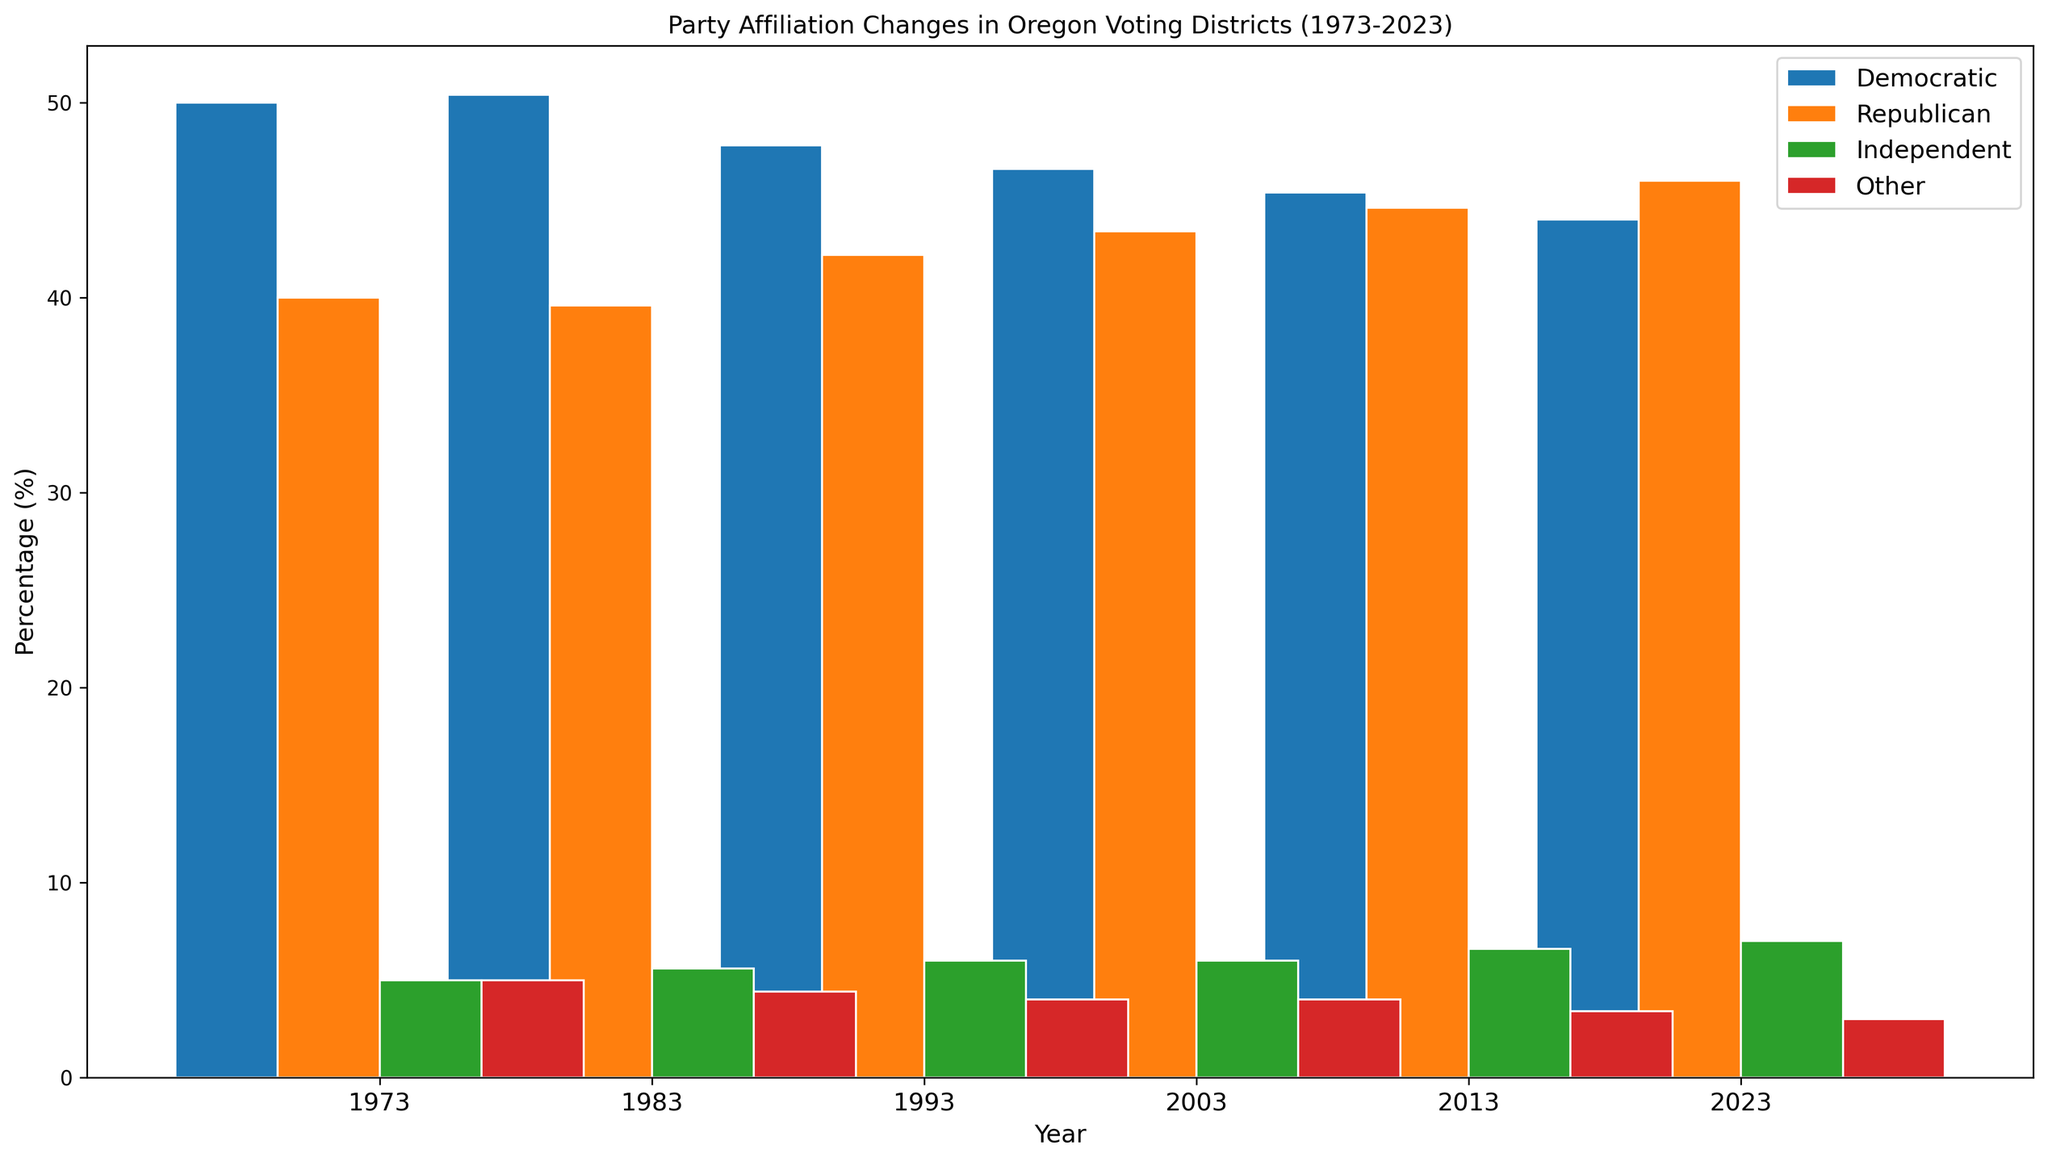What is the average percentage of Democratic affiliation across all years? Calculate the mean of the Democratic values for each year: (60+55+50+45+40+58+54+51+46+43+55+50+48+44+42+53+49+47+43+41+52+48+45+42+40+50+46+44+41+39) / 30 = 47.8
Answer: 47.8 Between which years did the Republican percentage in District 4 increase the most? The change in Republican percentages in District 4 are: 1973-1983: 44-45= -1, 1983-1993: 46-44=2, 1993-2003: 47-46=1, 2003-2013: 48-47=1, 2013-2023: 49-48=1. The highest increase is 2 between 1983-1993.
Answer: 1983-1993 Which district had the highest Independent affiliation percentage in 2023? From the data, see Independent percentages in 2023: District 1: 8%, District 2: 8%, District 3: 7%, District 4: 6%, District 5: 6%. District 1 and District 2 both had the highest Independent affiliation at 8%.
Answer: District 1 and District 2 What is the trend in percentage of Democratic affiliation in District 5 from 1973 to 2023? Observe the Democratic percentages for District 5 over years: 1973: 40%, 1983: 43%, 1993: 42%, 2003: 41%, 2013: 40%, 2023: 39%. The percentage slightly decreases over time.
Answer: Decreasing Compare the Democratic and Republican percentages in 1993 for District 3. Which is higher? From the data for District 3 in 1993: Democratic: 48%, Republican: 42%. Democratic percentage is higher.
Answer: Democratic What color represents the "Independent" party in the figure? Independents are represented by green bars in the figure as per the party_colors dictionary.
Answer: Green In what year do all districts show the lowest "Other" party affiliation percentage? Observing the "Other" affiliation percentages for all years: Consistently, the lowest "Other" percentage is 2% in 2013 and 2023.
Answer: 2013 and 2023 Which district exhibited the highest percentage increase in Republican affiliation from 1973 to 2023? Calculate the percentage increase for each district: 
District 1: 40-30=10%, 
District 2: 44-35=9%, 
District 3: 46-40=6%, 
District 4: 49-45=4%, 
District 5: 51-50=1%. District 1 had the highest increase of 10%.
Answer: District 1 What is the average Republican percentage across all districts in the year 2003? From 2003 data, the Republican percentages are: District 1: 37%, District 2: 41%, District 3: 43%, District 4: 47%, District 5: 49%. The average is (37+41+43+47+49) / 5 = 43.4%
Answer: 43.4% 